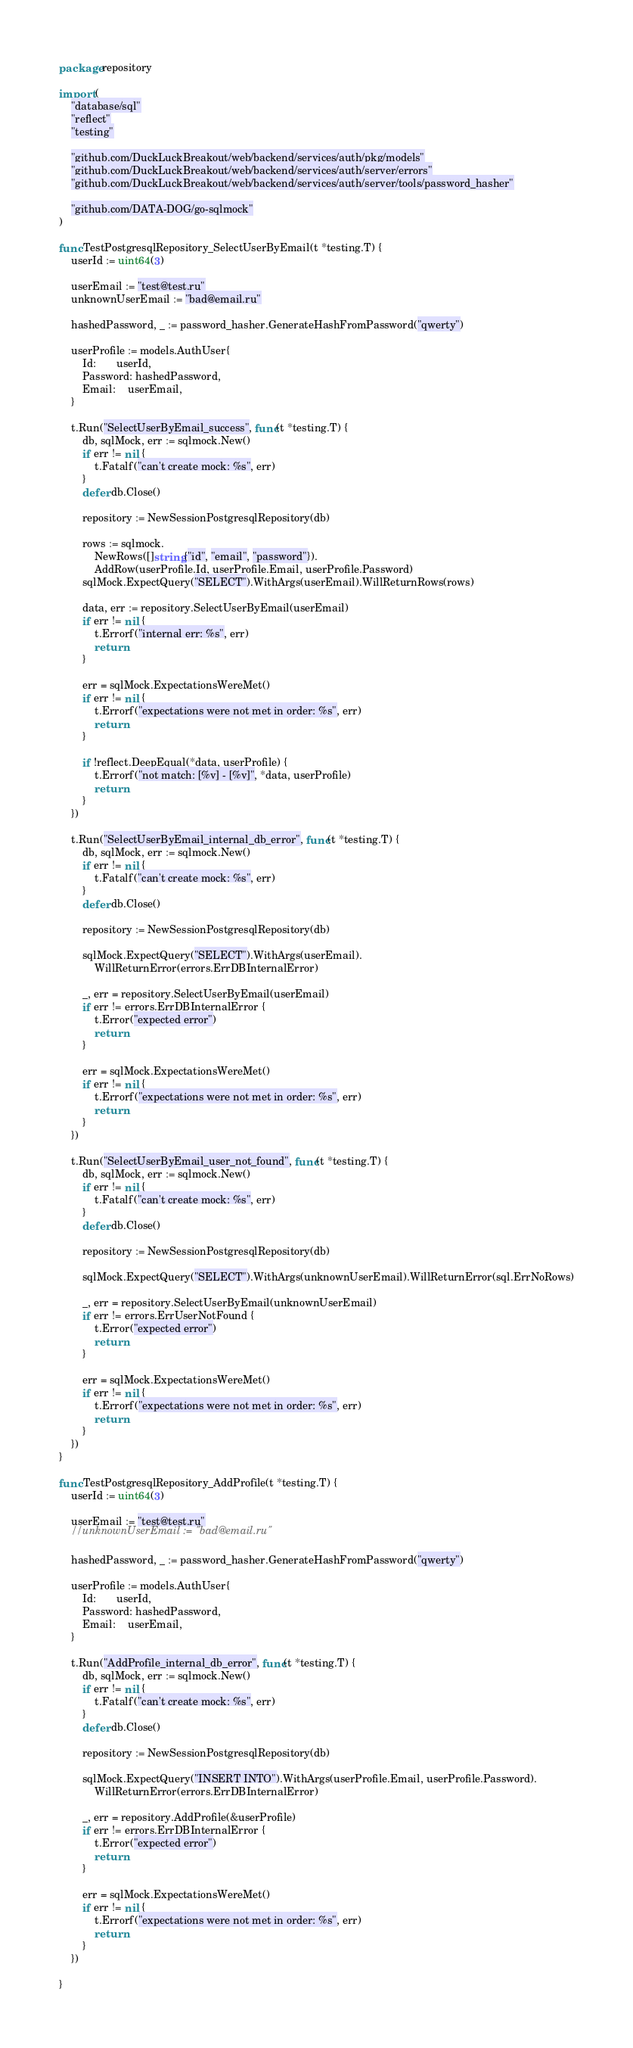<code> <loc_0><loc_0><loc_500><loc_500><_Go_>package repository

import (
	"database/sql"
	"reflect"
	"testing"

	"github.com/DuckLuckBreakout/web/backend/services/auth/pkg/models"
	"github.com/DuckLuckBreakout/web/backend/services/auth/server/errors"
	"github.com/DuckLuckBreakout/web/backend/services/auth/server/tools/password_hasher"

	"github.com/DATA-DOG/go-sqlmock"
)

func TestPostgresqlRepository_SelectUserByEmail(t *testing.T) {
	userId := uint64(3)

	userEmail := "test@test.ru"
	unknownUserEmail := "bad@email.ru"

	hashedPassword, _ := password_hasher.GenerateHashFromPassword("qwerty")

	userProfile := models.AuthUser{
		Id:       userId,
		Password: hashedPassword,
		Email:    userEmail,
	}

	t.Run("SelectUserByEmail_success", func(t *testing.T) {
		db, sqlMock, err := sqlmock.New()
		if err != nil {
			t.Fatalf("can't create mock: %s", err)
		}
		defer db.Close()

		repository := NewSessionPostgresqlRepository(db)

		rows := sqlmock.
			NewRows([]string{"id", "email", "password"}).
			AddRow(userProfile.Id, userProfile.Email, userProfile.Password)
		sqlMock.ExpectQuery("SELECT").WithArgs(userEmail).WillReturnRows(rows)

		data, err := repository.SelectUserByEmail(userEmail)
		if err != nil {
			t.Errorf("internal err: %s", err)
			return
		}

		err = sqlMock.ExpectationsWereMet()
		if err != nil {
			t.Errorf("expectations were not met in order: %s", err)
			return
		}

		if !reflect.DeepEqual(*data, userProfile) {
			t.Errorf("not match: [%v] - [%v]", *data, userProfile)
			return
		}
	})

	t.Run("SelectUserByEmail_internal_db_error", func(t *testing.T) {
		db, sqlMock, err := sqlmock.New()
		if err != nil {
			t.Fatalf("can't create mock: %s", err)
		}
		defer db.Close()

		repository := NewSessionPostgresqlRepository(db)

		sqlMock.ExpectQuery("SELECT").WithArgs(userEmail).
			WillReturnError(errors.ErrDBInternalError)

		_, err = repository.SelectUserByEmail(userEmail)
		if err != errors.ErrDBInternalError {
			t.Error("expected error")
			return
		}

		err = sqlMock.ExpectationsWereMet()
		if err != nil {
			t.Errorf("expectations were not met in order: %s", err)
			return
		}
	})

	t.Run("SelectUserByEmail_user_not_found", func(t *testing.T) {
		db, sqlMock, err := sqlmock.New()
		if err != nil {
			t.Fatalf("can't create mock: %s", err)
		}
		defer db.Close()

		repository := NewSessionPostgresqlRepository(db)

		sqlMock.ExpectQuery("SELECT").WithArgs(unknownUserEmail).WillReturnError(sql.ErrNoRows)

		_, err = repository.SelectUserByEmail(unknownUserEmail)
		if err != errors.ErrUserNotFound {
			t.Error("expected error")
			return
		}

		err = sqlMock.ExpectationsWereMet()
		if err != nil {
			t.Errorf("expectations were not met in order: %s", err)
			return
		}
	})
}

func TestPostgresqlRepository_AddProfile(t *testing.T) {
	userId := uint64(3)

	userEmail := "test@test.ru"
	//unknownUserEmail := "bad@email.ru"

	hashedPassword, _ := password_hasher.GenerateHashFromPassword("qwerty")

	userProfile := models.AuthUser{
		Id:       userId,
		Password: hashedPassword,
		Email:    userEmail,
	}

	t.Run("AddProfile_internal_db_error", func(t *testing.T) {
		db, sqlMock, err := sqlmock.New()
		if err != nil {
			t.Fatalf("can't create mock: %s", err)
		}
		defer db.Close()

		repository := NewSessionPostgresqlRepository(db)

		sqlMock.ExpectQuery("INSERT INTO").WithArgs(userProfile.Email, userProfile.Password).
			WillReturnError(errors.ErrDBInternalError)

		_, err = repository.AddProfile(&userProfile)
		if err != errors.ErrDBInternalError {
			t.Error("expected error")
			return
		}

		err = sqlMock.ExpectationsWereMet()
		if err != nil {
			t.Errorf("expectations were not met in order: %s", err)
			return
		}
	})

}
</code> 